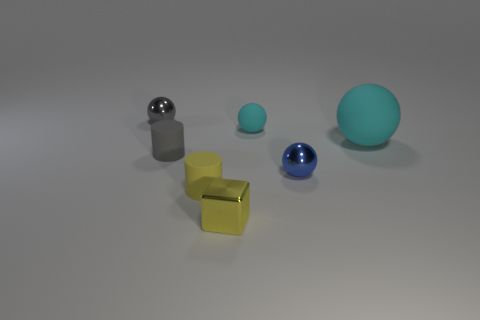Can you describe the shapes and colors of the objects in the image? Certainly! The image depicts a collection of geometric objects. There's a reflective sphere and a smaller, less shiny one, both in shades of gray. Additionally, we have two cubes—one golden and reflective, the other gray and matte—and there's a larger teal sphere that's matte as well. 